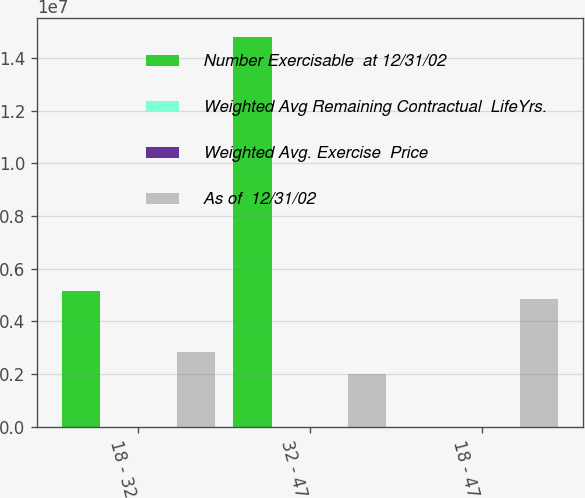Convert chart to OTSL. <chart><loc_0><loc_0><loc_500><loc_500><stacked_bar_chart><ecel><fcel>18 - 32<fcel>32 - 47<fcel>18 - 47<nl><fcel>Number Exercisable  at 12/31/02<fcel>5.14484e+06<fcel>1.47983e+07<fcel>39.52<nl><fcel>Weighted Avg Remaining Contractual  LifeYrs.<fcel>7.2<fcel>8.6<fcel>8.2<nl><fcel>Weighted Avg. Exercise  Price<fcel>25.28<fcel>39.52<fcel>35.85<nl><fcel>As of  12/31/02<fcel>2.85058e+06<fcel>1.98694e+06<fcel>4.83751e+06<nl></chart> 